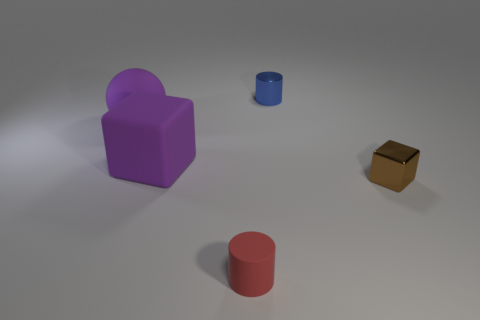Is there any object that appears to be in motion or out of place? No objects in the image give the impression of motion; all items are stationary and evenly spaced. The composition is orderly, with no particular item seeming out of place. How could these objects be used to explain basic geometry to a child? These objects serve as excellent hands-on tools for introducing basic geometric shapes. The cube, cylinder, and rectangular prism can help a child visualize and understand three-dimensional forms and the concept of volume. 